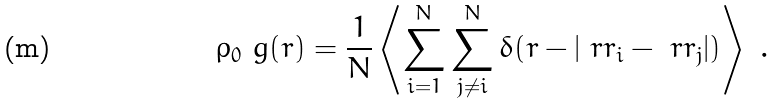<formula> <loc_0><loc_0><loc_500><loc_500>\rho _ { 0 } \ g ( r ) = \frac { 1 } { N } \left \langle \sum _ { i = 1 } ^ { N } \sum _ { j \neq i } ^ { N } \delta ( r - | \ r r _ { i } - \ r r _ { j } | ) \right \rangle \ .</formula> 